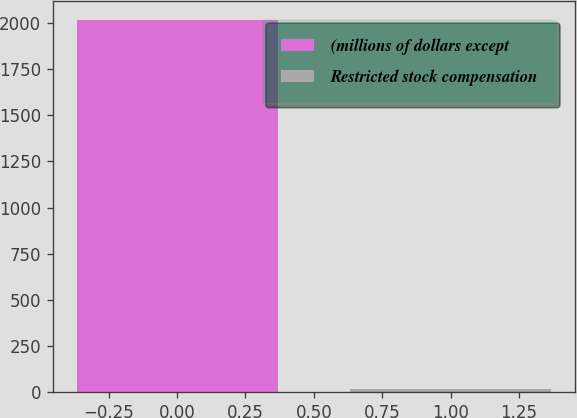Convert chart to OTSL. <chart><loc_0><loc_0><loc_500><loc_500><bar_chart><fcel>(millions of dollars except<fcel>Restricted stock compensation<nl><fcel>2016<fcel>19.5<nl></chart> 